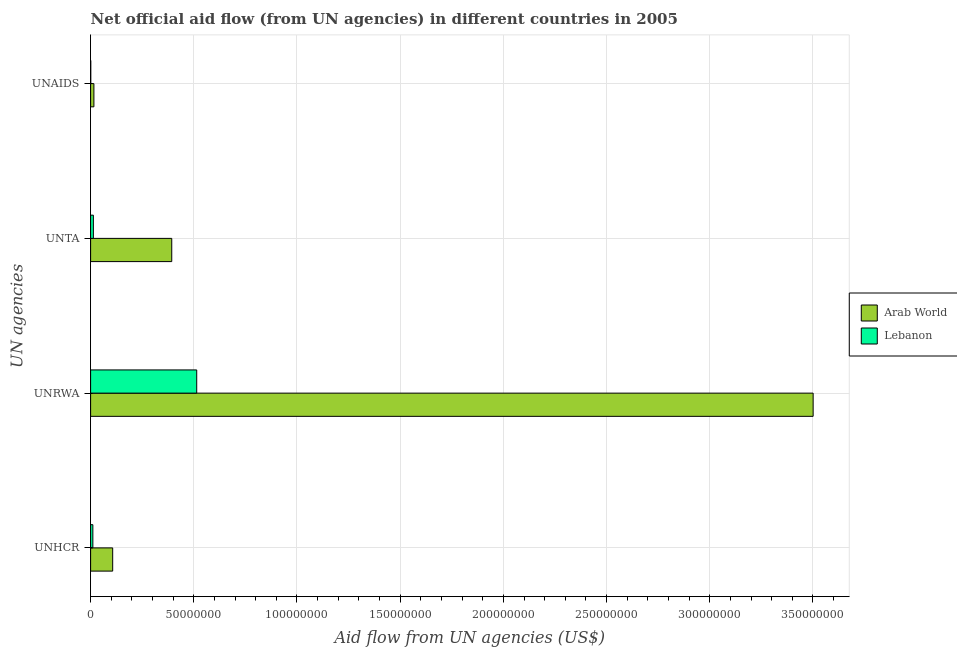How many groups of bars are there?
Keep it short and to the point. 4. How many bars are there on the 4th tick from the bottom?
Provide a short and direct response. 2. What is the label of the 1st group of bars from the top?
Provide a succinct answer. UNAIDS. What is the amount of aid given by unrwa in Arab World?
Provide a succinct answer. 3.50e+08. Across all countries, what is the maximum amount of aid given by unrwa?
Your response must be concise. 3.50e+08. Across all countries, what is the minimum amount of aid given by unaids?
Your answer should be very brief. 8.00e+04. In which country was the amount of aid given by unta maximum?
Your answer should be compact. Arab World. In which country was the amount of aid given by unrwa minimum?
Provide a succinct answer. Lebanon. What is the total amount of aid given by unaids in the graph?
Your response must be concise. 1.68e+06. What is the difference between the amount of aid given by unrwa in Arab World and that in Lebanon?
Provide a succinct answer. 2.99e+08. What is the difference between the amount of aid given by unrwa in Lebanon and the amount of aid given by unhcr in Arab World?
Give a very brief answer. 4.07e+07. What is the average amount of aid given by unrwa per country?
Your answer should be compact. 2.01e+08. What is the difference between the amount of aid given by unta and amount of aid given by unrwa in Arab World?
Provide a succinct answer. -3.11e+08. In how many countries, is the amount of aid given by unrwa greater than 330000000 US$?
Your response must be concise. 1. What is the ratio of the amount of aid given by unrwa in Lebanon to that in Arab World?
Your response must be concise. 0.15. Is the amount of aid given by unta in Arab World less than that in Lebanon?
Your answer should be compact. No. What is the difference between the highest and the second highest amount of aid given by unhcr?
Provide a short and direct response. 9.61e+06. What is the difference between the highest and the lowest amount of aid given by unhcr?
Give a very brief answer. 9.61e+06. In how many countries, is the amount of aid given by unhcr greater than the average amount of aid given by unhcr taken over all countries?
Your answer should be compact. 1. What does the 1st bar from the top in UNTA represents?
Offer a terse response. Lebanon. What does the 2nd bar from the bottom in UNAIDS represents?
Offer a terse response. Lebanon. How many bars are there?
Provide a succinct answer. 8. What is the difference between two consecutive major ticks on the X-axis?
Offer a terse response. 5.00e+07. How many legend labels are there?
Ensure brevity in your answer.  2. How are the legend labels stacked?
Provide a succinct answer. Vertical. What is the title of the graph?
Your answer should be very brief. Net official aid flow (from UN agencies) in different countries in 2005. Does "Poland" appear as one of the legend labels in the graph?
Provide a succinct answer. No. What is the label or title of the X-axis?
Your answer should be compact. Aid flow from UN agencies (US$). What is the label or title of the Y-axis?
Provide a succinct answer. UN agencies. What is the Aid flow from UN agencies (US$) in Arab World in UNHCR?
Provide a succinct answer. 1.07e+07. What is the Aid flow from UN agencies (US$) of Lebanon in UNHCR?
Offer a terse response. 1.09e+06. What is the Aid flow from UN agencies (US$) of Arab World in UNRWA?
Your answer should be compact. 3.50e+08. What is the Aid flow from UN agencies (US$) of Lebanon in UNRWA?
Your answer should be very brief. 5.14e+07. What is the Aid flow from UN agencies (US$) in Arab World in UNTA?
Make the answer very short. 3.93e+07. What is the Aid flow from UN agencies (US$) in Lebanon in UNTA?
Provide a short and direct response. 1.34e+06. What is the Aid flow from UN agencies (US$) in Arab World in UNAIDS?
Ensure brevity in your answer.  1.60e+06. Across all UN agencies, what is the maximum Aid flow from UN agencies (US$) of Arab World?
Provide a succinct answer. 3.50e+08. Across all UN agencies, what is the maximum Aid flow from UN agencies (US$) of Lebanon?
Offer a very short reply. 5.14e+07. Across all UN agencies, what is the minimum Aid flow from UN agencies (US$) of Arab World?
Give a very brief answer. 1.60e+06. What is the total Aid flow from UN agencies (US$) of Arab World in the graph?
Your answer should be very brief. 4.02e+08. What is the total Aid flow from UN agencies (US$) in Lebanon in the graph?
Offer a very short reply. 5.39e+07. What is the difference between the Aid flow from UN agencies (US$) of Arab World in UNHCR and that in UNRWA?
Offer a very short reply. -3.39e+08. What is the difference between the Aid flow from UN agencies (US$) in Lebanon in UNHCR and that in UNRWA?
Provide a short and direct response. -5.03e+07. What is the difference between the Aid flow from UN agencies (US$) of Arab World in UNHCR and that in UNTA?
Give a very brief answer. -2.86e+07. What is the difference between the Aid flow from UN agencies (US$) of Arab World in UNHCR and that in UNAIDS?
Ensure brevity in your answer.  9.10e+06. What is the difference between the Aid flow from UN agencies (US$) of Lebanon in UNHCR and that in UNAIDS?
Your answer should be compact. 1.01e+06. What is the difference between the Aid flow from UN agencies (US$) in Arab World in UNRWA and that in UNTA?
Offer a terse response. 3.11e+08. What is the difference between the Aid flow from UN agencies (US$) in Lebanon in UNRWA and that in UNTA?
Your answer should be very brief. 5.01e+07. What is the difference between the Aid flow from UN agencies (US$) in Arab World in UNRWA and that in UNAIDS?
Provide a short and direct response. 3.49e+08. What is the difference between the Aid flow from UN agencies (US$) in Lebanon in UNRWA and that in UNAIDS?
Provide a succinct answer. 5.13e+07. What is the difference between the Aid flow from UN agencies (US$) of Arab World in UNTA and that in UNAIDS?
Offer a terse response. 3.77e+07. What is the difference between the Aid flow from UN agencies (US$) in Lebanon in UNTA and that in UNAIDS?
Give a very brief answer. 1.26e+06. What is the difference between the Aid flow from UN agencies (US$) of Arab World in UNHCR and the Aid flow from UN agencies (US$) of Lebanon in UNRWA?
Ensure brevity in your answer.  -4.07e+07. What is the difference between the Aid flow from UN agencies (US$) of Arab World in UNHCR and the Aid flow from UN agencies (US$) of Lebanon in UNTA?
Your answer should be very brief. 9.36e+06. What is the difference between the Aid flow from UN agencies (US$) in Arab World in UNHCR and the Aid flow from UN agencies (US$) in Lebanon in UNAIDS?
Provide a succinct answer. 1.06e+07. What is the difference between the Aid flow from UN agencies (US$) in Arab World in UNRWA and the Aid flow from UN agencies (US$) in Lebanon in UNTA?
Offer a very short reply. 3.49e+08. What is the difference between the Aid flow from UN agencies (US$) in Arab World in UNRWA and the Aid flow from UN agencies (US$) in Lebanon in UNAIDS?
Offer a very short reply. 3.50e+08. What is the difference between the Aid flow from UN agencies (US$) of Arab World in UNTA and the Aid flow from UN agencies (US$) of Lebanon in UNAIDS?
Keep it short and to the point. 3.92e+07. What is the average Aid flow from UN agencies (US$) in Arab World per UN agencies?
Make the answer very short. 1.00e+08. What is the average Aid flow from UN agencies (US$) of Lebanon per UN agencies?
Make the answer very short. 1.35e+07. What is the difference between the Aid flow from UN agencies (US$) in Arab World and Aid flow from UN agencies (US$) in Lebanon in UNHCR?
Your answer should be compact. 9.61e+06. What is the difference between the Aid flow from UN agencies (US$) in Arab World and Aid flow from UN agencies (US$) in Lebanon in UNRWA?
Give a very brief answer. 2.99e+08. What is the difference between the Aid flow from UN agencies (US$) in Arab World and Aid flow from UN agencies (US$) in Lebanon in UNTA?
Keep it short and to the point. 3.80e+07. What is the difference between the Aid flow from UN agencies (US$) in Arab World and Aid flow from UN agencies (US$) in Lebanon in UNAIDS?
Offer a very short reply. 1.52e+06. What is the ratio of the Aid flow from UN agencies (US$) of Arab World in UNHCR to that in UNRWA?
Offer a terse response. 0.03. What is the ratio of the Aid flow from UN agencies (US$) in Lebanon in UNHCR to that in UNRWA?
Make the answer very short. 0.02. What is the ratio of the Aid flow from UN agencies (US$) of Arab World in UNHCR to that in UNTA?
Provide a short and direct response. 0.27. What is the ratio of the Aid flow from UN agencies (US$) in Lebanon in UNHCR to that in UNTA?
Give a very brief answer. 0.81. What is the ratio of the Aid flow from UN agencies (US$) in Arab World in UNHCR to that in UNAIDS?
Provide a short and direct response. 6.69. What is the ratio of the Aid flow from UN agencies (US$) of Lebanon in UNHCR to that in UNAIDS?
Keep it short and to the point. 13.62. What is the ratio of the Aid flow from UN agencies (US$) in Arab World in UNRWA to that in UNTA?
Make the answer very short. 8.9. What is the ratio of the Aid flow from UN agencies (US$) in Lebanon in UNRWA to that in UNTA?
Your answer should be compact. 38.37. What is the ratio of the Aid flow from UN agencies (US$) of Arab World in UNRWA to that in UNAIDS?
Keep it short and to the point. 218.82. What is the ratio of the Aid flow from UN agencies (US$) of Lebanon in UNRWA to that in UNAIDS?
Your answer should be very brief. 642.75. What is the ratio of the Aid flow from UN agencies (US$) in Arab World in UNTA to that in UNAIDS?
Provide a succinct answer. 24.57. What is the ratio of the Aid flow from UN agencies (US$) of Lebanon in UNTA to that in UNAIDS?
Provide a succinct answer. 16.75. What is the difference between the highest and the second highest Aid flow from UN agencies (US$) in Arab World?
Offer a terse response. 3.11e+08. What is the difference between the highest and the second highest Aid flow from UN agencies (US$) of Lebanon?
Your response must be concise. 5.01e+07. What is the difference between the highest and the lowest Aid flow from UN agencies (US$) of Arab World?
Give a very brief answer. 3.49e+08. What is the difference between the highest and the lowest Aid flow from UN agencies (US$) of Lebanon?
Your answer should be compact. 5.13e+07. 